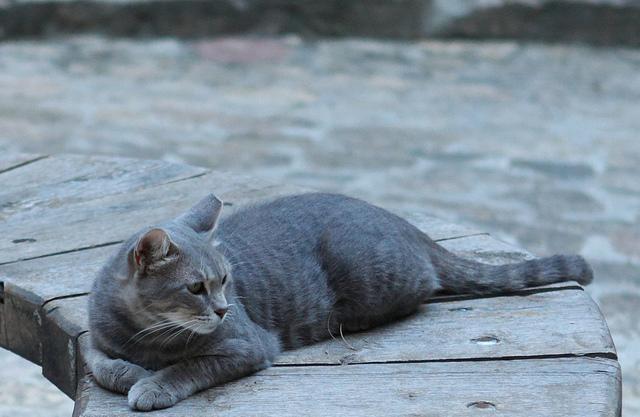How many benches are visible?
Give a very brief answer. 1. 